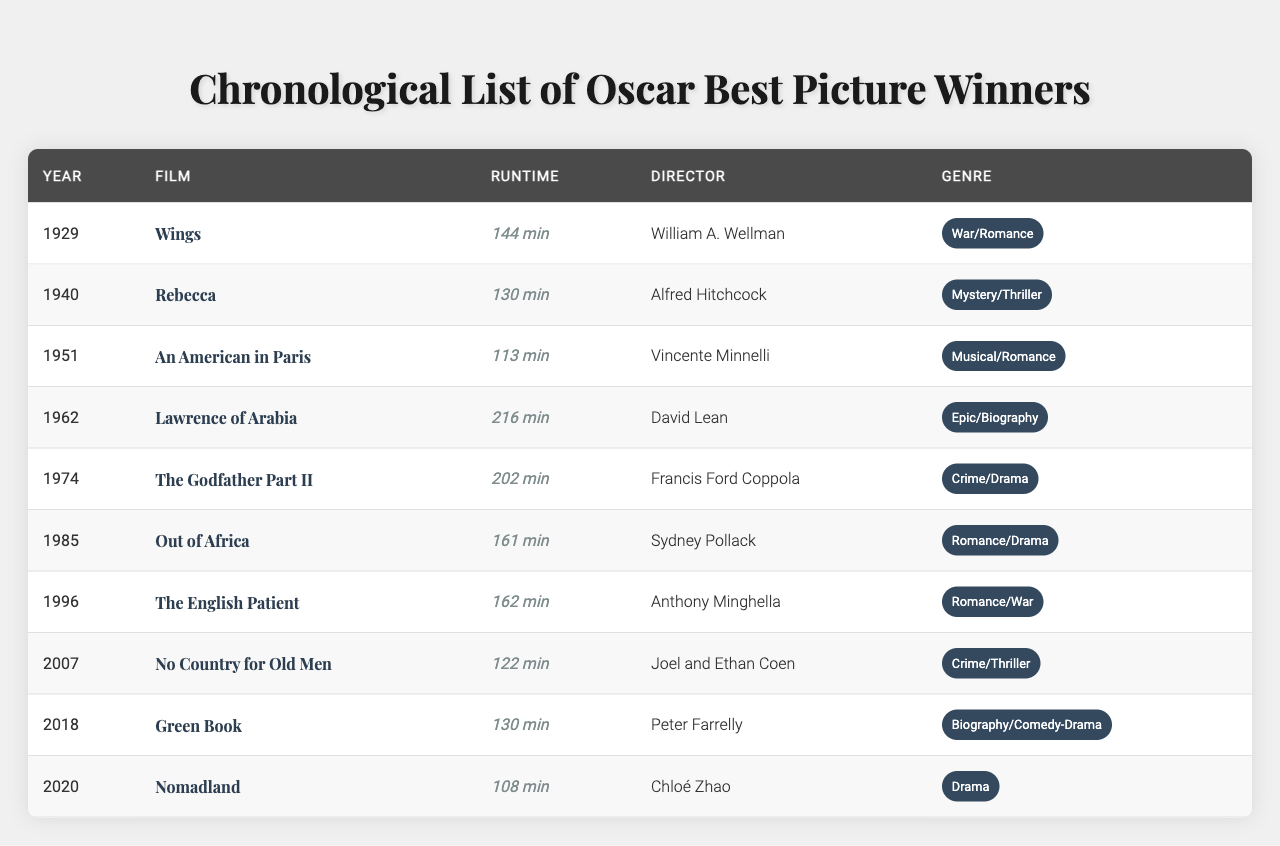What is the runtime of "Wings"? The table lists the runtime of "Wings" as 144 minutes.
Answer: 144 minutes Who directed "The Godfather Part II"? The director of "The Godfather Part II" is Francis Ford Coppola, as indicated in the table.
Answer: Francis Ford Coppola How many films have a runtime over 160 minutes? The table shows two films with a runtime over 160 minutes: "Lawrence of Arabia" (216 minutes) and "The English Patient" (162 minutes).
Answer: 2 films What film won Best Picture in both 1940 and 1985? The table shows that no film won Best Picture in both 1940 and 1985, as they are different entries ("Rebecca" in 1940 and "Out of Africa" in 1985).
Answer: False Which film has the shortest runtime? The shortest runtime is found in "Nomadland," which has 108 minutes listed in the table.
Answer: "Nomadland" What is the average runtime of the listed films? The total runtime is calculated as follows: 144 + 130 + 113 + 216 + 202 + 161 + 162 + 122 + 130 + 108 = 1343 minutes. There are 10 films, so the average runtime is 1343 / 10 = 134.3 minutes.
Answer: 134.3 minutes How many films in the table belong to the genre "Romance"? The table shows three films under the "Romance" genre: "Wings," "Out of Africa," and "The English Patient."
Answer: 3 films Which director is associated with the most films in the table? Checking the table, it appears that no director is listed with multiple films present in this selection. Each film has a unique director.
Answer: None Is there any film that has exactly 130 minutes runtime? Yes, both "Rebecca" and "Green Book" have a runtime of exactly 130 minutes, as shown in the table.
Answer: Yes What is the difference in runtime between "Lawrence of Arabia" and "An American in Paris"? "Lawrence of Arabia" has a runtime of 216 minutes and "An American in Paris" has 113 minutes. The difference is 216 - 113 = 103 minutes.
Answer: 103 minutes 